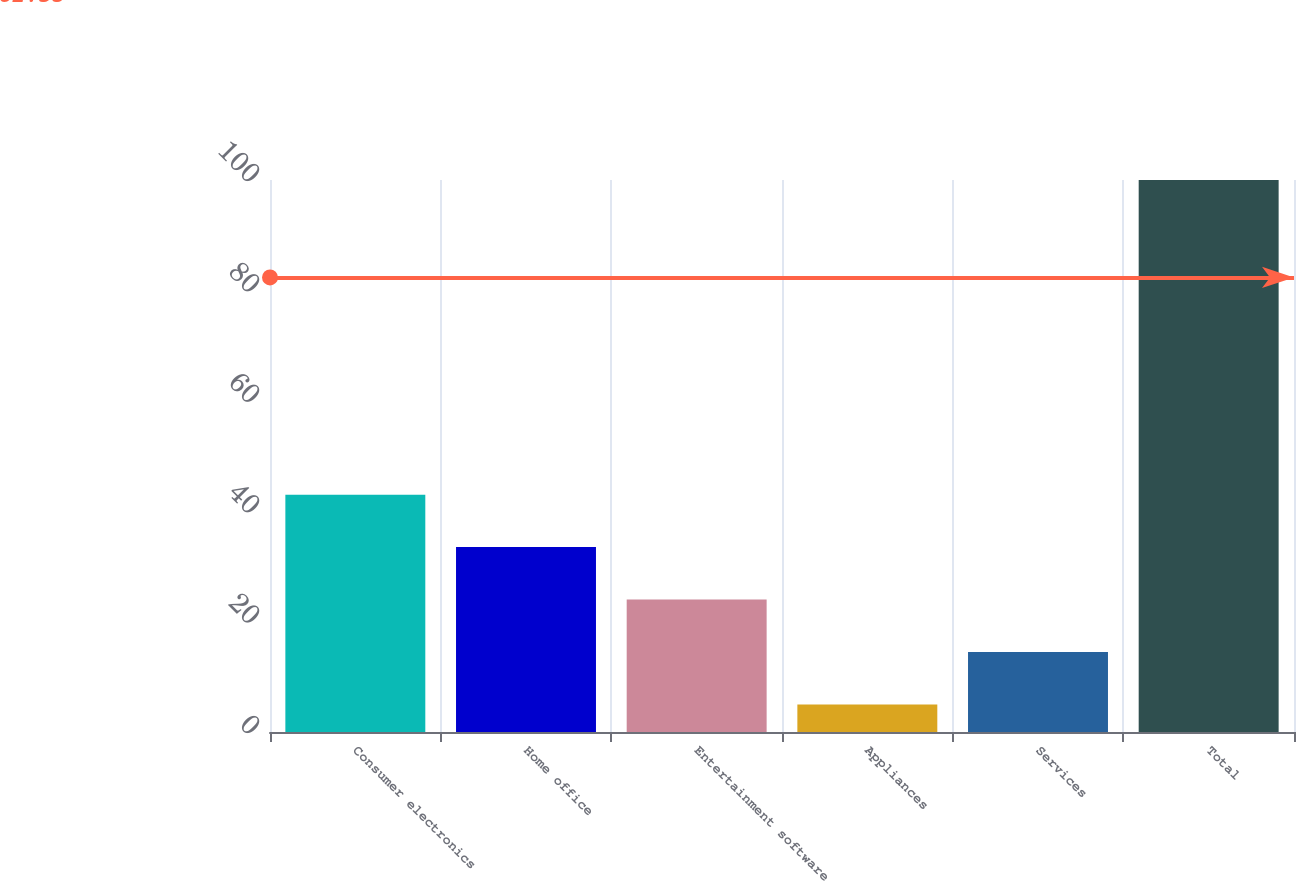Convert chart to OTSL. <chart><loc_0><loc_0><loc_500><loc_500><bar_chart><fcel>Consumer electronics<fcel>Home office<fcel>Entertainment software<fcel>Appliances<fcel>Services<fcel>Total<nl><fcel>43<fcel>33.5<fcel>24<fcel>5<fcel>14.5<fcel>100<nl></chart> 